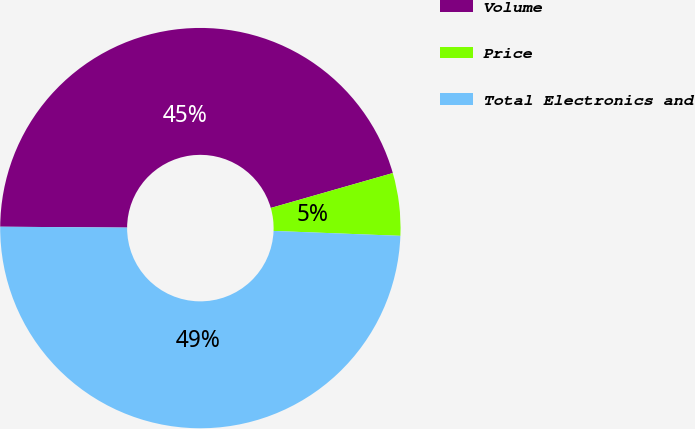<chart> <loc_0><loc_0><loc_500><loc_500><pie_chart><fcel>Volume<fcel>Price<fcel>Total Electronics and<nl><fcel>45.45%<fcel>5.05%<fcel>49.49%<nl></chart> 